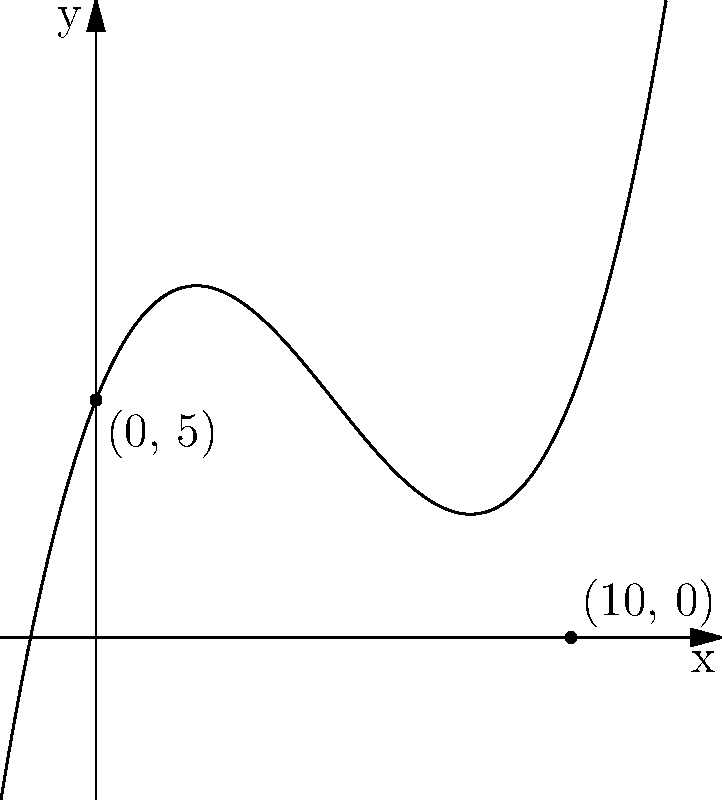You're designing an ornate fountain for your new mansion's courtyard. The water's trajectory is described by the polynomial equation $f(x) = 0.05x^3 - 0.75x^2 + 2.5x + 5$, where $x$ is the horizontal distance and $f(x)$ is the height, both measured in meters. What is the maximum horizontal distance the water will travel before hitting the ground? To find the maximum horizontal distance, we need to determine where the function intersects the x-axis (i.e., where $f(x) = 0$).

1) We can see from the graph that the function intersects the x-axis at two points: (0,5) and (10,0).

2) The point (0,5) represents the starting point of the water jet.

3) The point (10,0) represents where the water hits the ground.

4) Therefore, the horizontal distance traveled by the water is the x-coordinate of the second intersection point, which is 10 meters.

This makes sense in the context of a luxurious mansion, as a large, impressive fountain with a 10-meter reach would be a stunning centerpiece for a courtyard.
Answer: 10 meters 